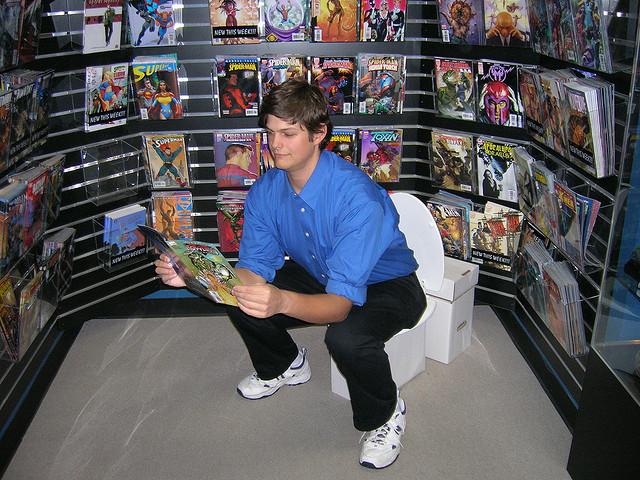Is that a storage box behind the toilet?
Be succinct. Yes. How can you tell he isn't actually using the toilet?
Write a very short answer. Pants are up. What section of the market is the man in?
Answer briefly. Comics. What is the man reading?
Short answer required. Comic book. What is the child holding?
Concise answer only. Comic. What is the man holding?
Short answer required. Comic book. 